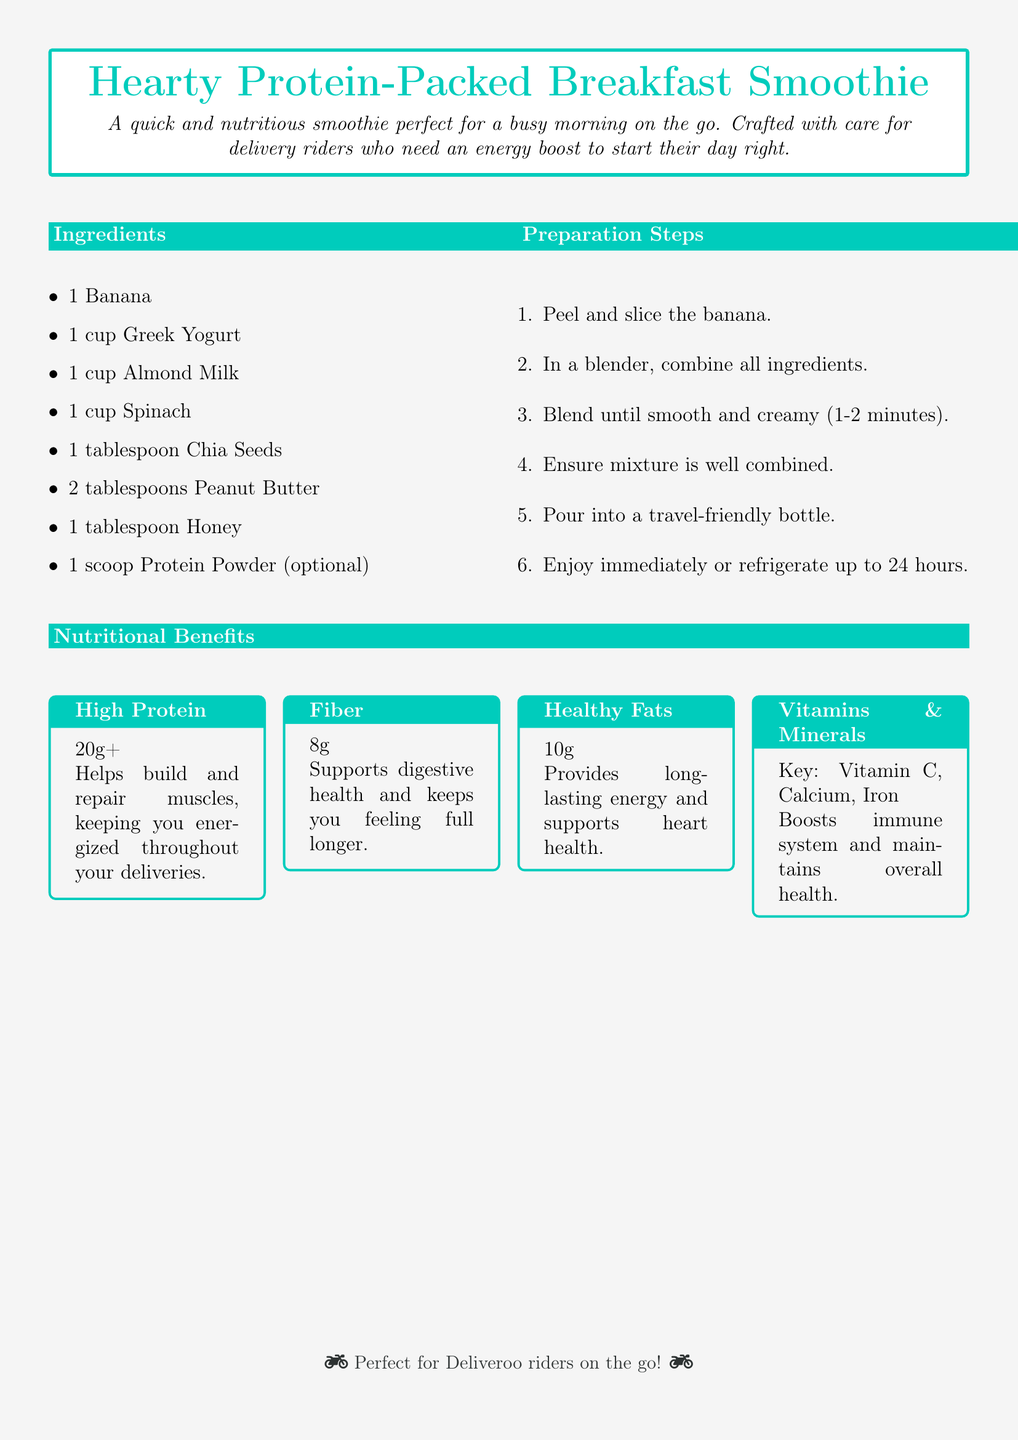What are the ingredients? The ingredients are listed in the "Ingredients" section of the document, which includes banana, Greek yogurt, almond milk, spinach, chia seeds, peanut butter, honey, and optional protein powder.
Answer: Banana, Greek Yogurt, Almond Milk, Spinach, Chia Seeds, Peanut Butter, Honey, Protein Powder How long should you blend the ingredients? The preparation steps specify that the ingredients should be blended until smooth and creamy for 1-2 minutes.
Answer: 1-2 minutes What is the protein content in the smoothie? The nutritional benefits section indicates that the smoothie contains over 20g of protein.
Answer: 20g+ What vitamins and minerals are highlighted? The nutritional benefits mentions key vitamins and minerals, specifically Vitamin C, Calcium, and Iron.
Answer: Vitamin C, Calcium, Iron What is the main purpose of this smoothie? The introduction describes the smoothie as a quick and nutritious option for busy mornings, especially for delivery riders needing energy.
Answer: Energy boost What type of recipe is this? The document is a recipe card featuring a breakfast smoothie tailored for quick preparation.
Answer: Breakfast smoothie How many tablespoons of peanut butter are needed? The ingredients list specifies that 2 tablespoons of peanut butter are required for the smoothie.
Answer: 2 tablespoons What dietary need does this smoothie address? The nutritional benefits indicate that the smoothie provides high protein, which helps build and repair muscles, catering to active individuals like delivery riders.
Answer: High protein 